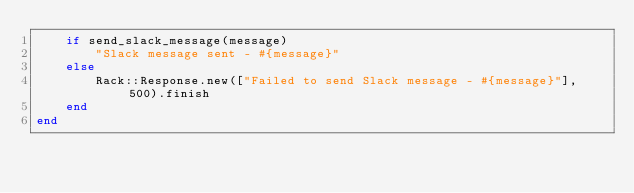<code> <loc_0><loc_0><loc_500><loc_500><_Ruby_>	if send_slack_message(message)
		"Slack message sent - #{message}"
	else
		Rack::Response.new(["Failed to send Slack message - #{message}"], 500).finish
	end
end
</code> 